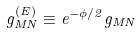Convert formula to latex. <formula><loc_0><loc_0><loc_500><loc_500>g ^ { ( E ) } _ { M N } \equiv e ^ { - \phi / 2 } g _ { M N }</formula> 